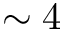<formula> <loc_0><loc_0><loc_500><loc_500>\sim 4</formula> 